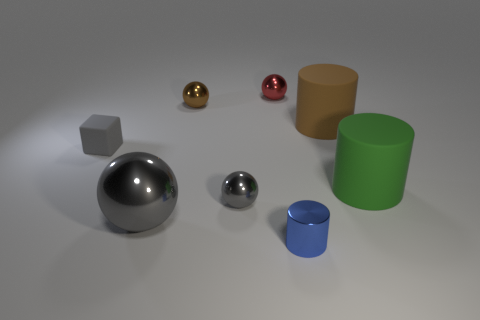The tiny metallic object that is in front of the brown metallic ball and to the left of the tiny red metallic ball is what color?
Your answer should be very brief. Gray. Does the large ball have the same color as the tiny metallic sphere in front of the large green matte cylinder?
Offer a terse response. Yes. What is the size of the thing that is both on the left side of the brown shiny sphere and in front of the big green cylinder?
Make the answer very short. Large. How many other objects are there of the same color as the large sphere?
Give a very brief answer. 2. What is the size of the cylinder that is behind the small object that is to the left of the big thing that is left of the small red object?
Ensure brevity in your answer.  Large. Are there any spheres behind the brown metallic thing?
Your answer should be compact. Yes. Do the brown cylinder and the red metallic thing behind the green matte cylinder have the same size?
Your answer should be very brief. No. What number of other things are made of the same material as the large ball?
Keep it short and to the point. 4. There is a metallic object that is both to the right of the small gray metal sphere and behind the big metal ball; what is its shape?
Make the answer very short. Sphere. Do the rubber thing that is behind the small gray matte block and the brown object that is left of the tiny cylinder have the same size?
Provide a short and direct response. No. 